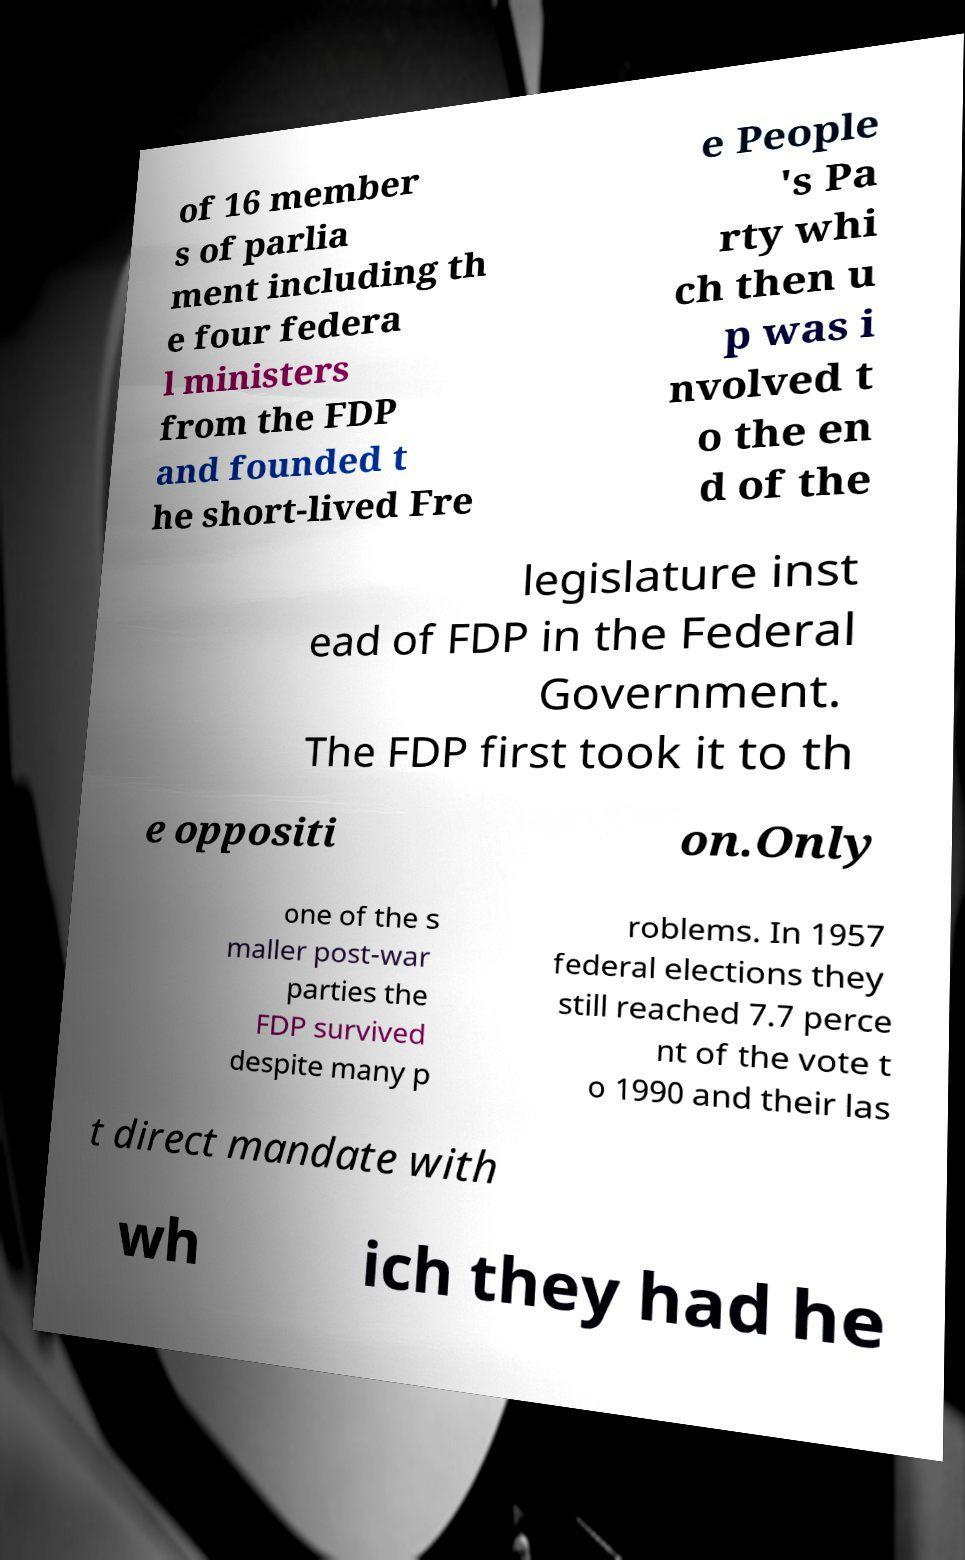I need the written content from this picture converted into text. Can you do that? of 16 member s of parlia ment including th e four federa l ministers from the FDP and founded t he short-lived Fre e People 's Pa rty whi ch then u p was i nvolved t o the en d of the legislature inst ead of FDP in the Federal Government. The FDP first took it to th e oppositi on.Only one of the s maller post-war parties the FDP survived despite many p roblems. In 1957 federal elections they still reached 7.7 perce nt of the vote t o 1990 and their las t direct mandate with wh ich they had he 